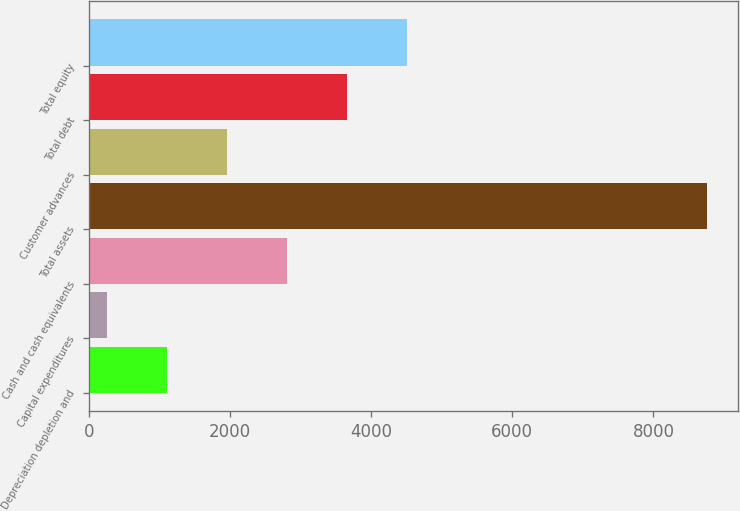<chart> <loc_0><loc_0><loc_500><loc_500><bar_chart><fcel>Depreciation depletion and<fcel>Capital expenditures<fcel>Cash and cash equivalents<fcel>Total assets<fcel>Customer advances<fcel>Total debt<fcel>Total equity<nl><fcel>1108.14<fcel>258.1<fcel>2808.22<fcel>8758.5<fcel>1958.18<fcel>3658.26<fcel>4508.3<nl></chart> 